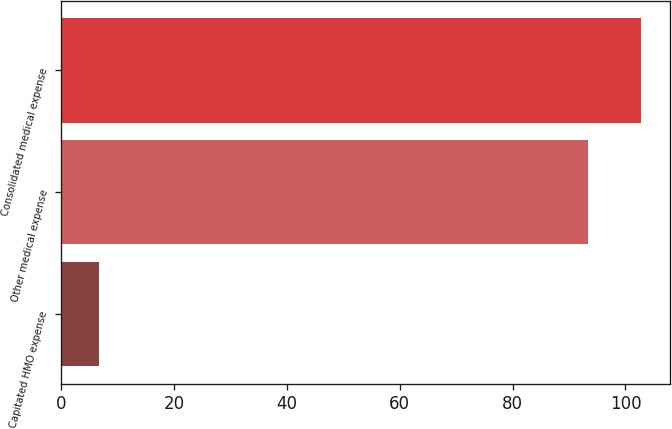Convert chart to OTSL. <chart><loc_0><loc_0><loc_500><loc_500><bar_chart><fcel>Capitated HMO expense<fcel>Other medical expense<fcel>Consolidated medical expense<nl><fcel>6.6<fcel>93.4<fcel>102.74<nl></chart> 